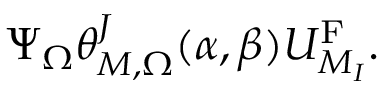Convert formula to latex. <formula><loc_0><loc_0><loc_500><loc_500>\Psi _ { \Omega } \theta _ { M , \Omega } ^ { J } ( \alpha , \beta ) U _ { M _ { I } } ^ { F } .</formula> 